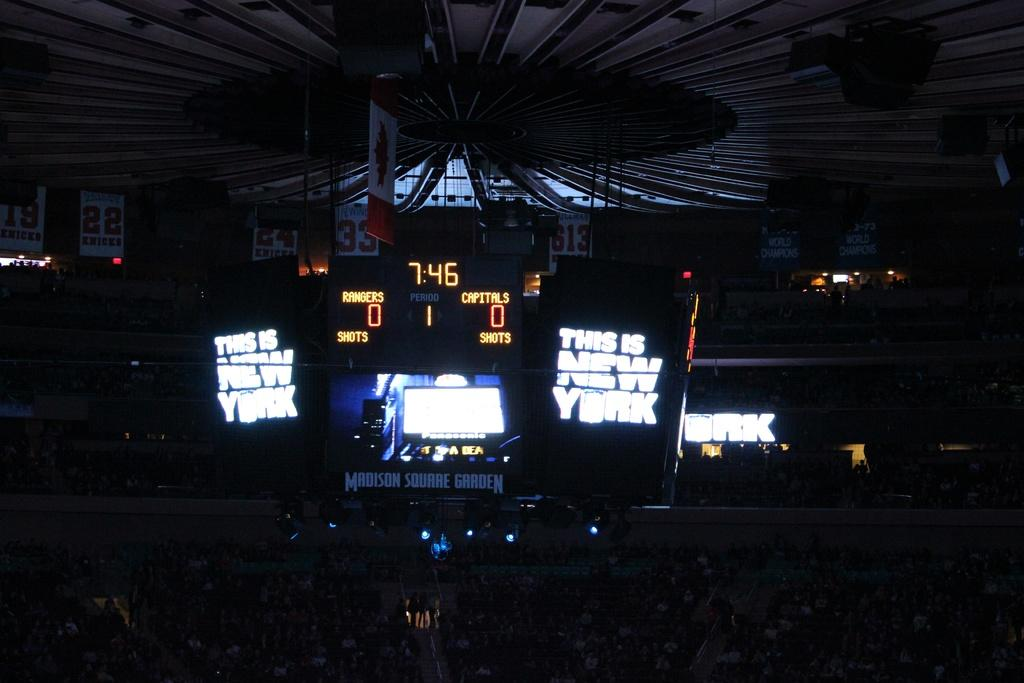<image>
Offer a succinct explanation of the picture presented. A New York hockey score board shows that the game is tied at zero zero. 